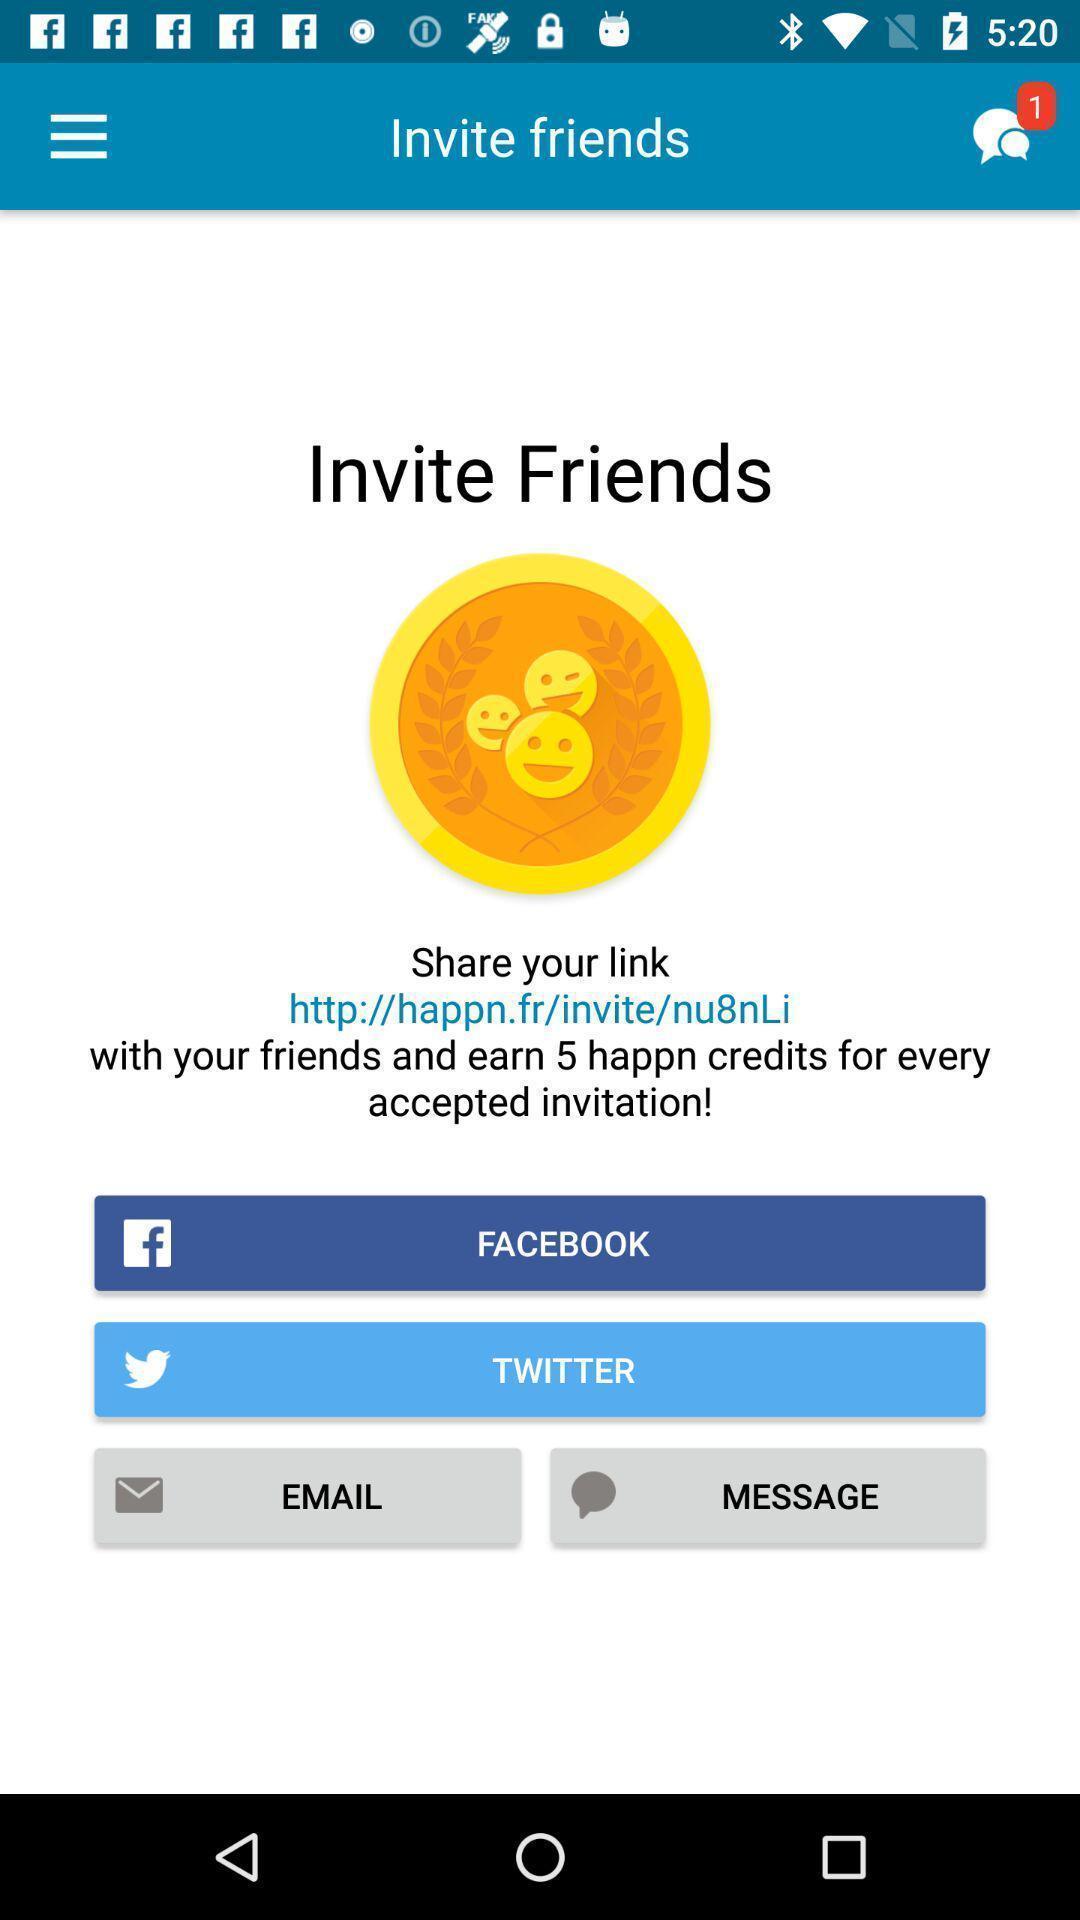Provide a description of this screenshot. Screen asks to invite friends. 